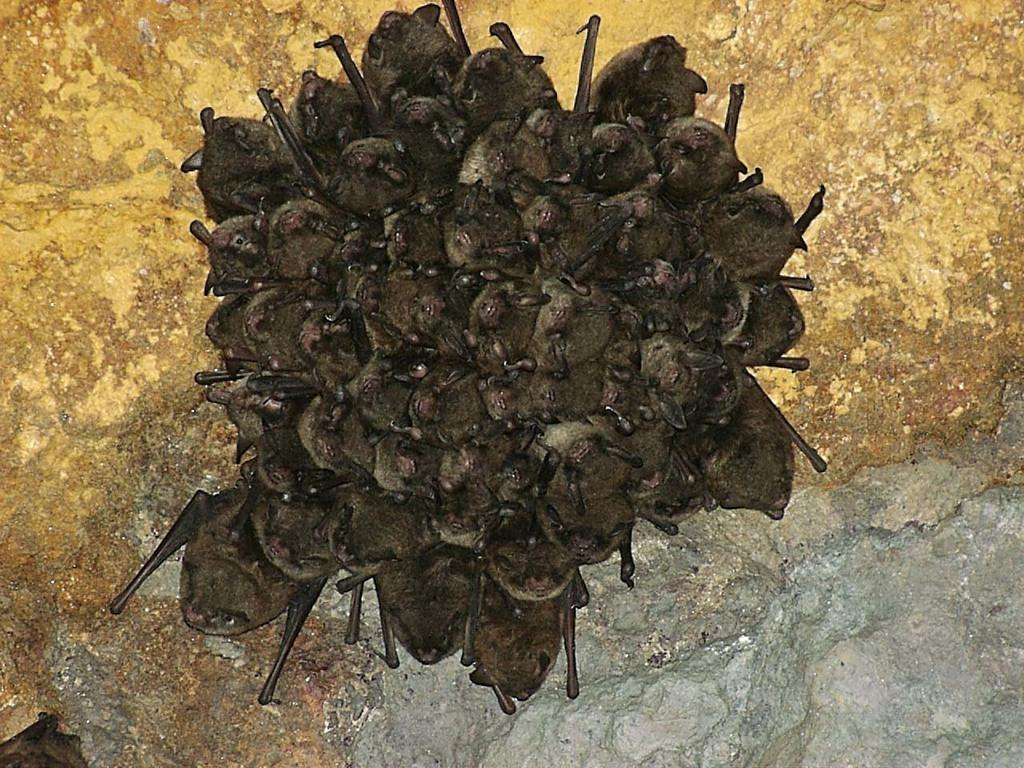What type of animals are present in the image? There are many bats in the picture. Can you describe any other objects or features in the image? There is a stone beside the bats. What type of building can be seen in the background of the image? There is no building present in the image; it only features bats and a stone. 